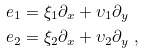<formula> <loc_0><loc_0><loc_500><loc_500>& e _ { 1 } = \xi _ { 1 } \partial _ { x } + \upsilon _ { 1 } \partial _ { y } \\ & e _ { 2 } = \xi _ { 2 } \partial _ { x } + \upsilon _ { 2 } \partial _ { y } \ ,</formula> 